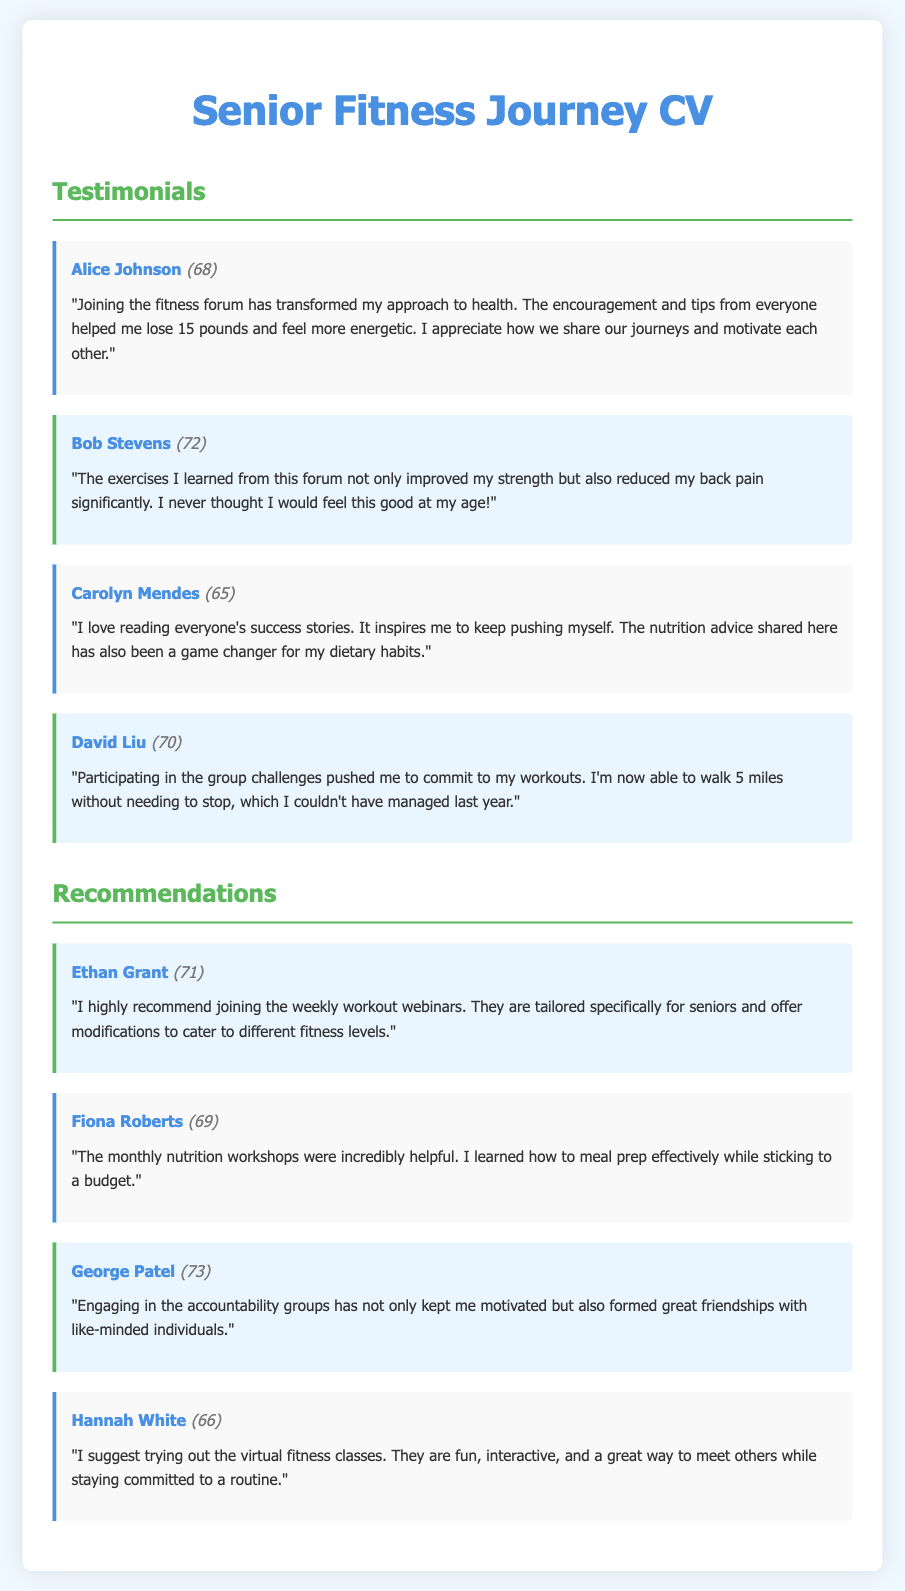What is the name of the first person to give a testimonial? The first testimonial is provided by Alice Johnson.
Answer: Alice Johnson How old is Bob Stevens? Bob Stevens is mentioned with his age given in parentheses.
Answer: 72 What was the weight loss mentioned by Alice Johnson? Alice Johnson states that she lost a specific amount of weight in her testimonial.
Answer: 15 pounds Who recommends joining the weekly workout webinars? The name associated with this recommendation is stated in the document.
Answer: Ethan Grant Which testimonial mentions improved strength? The statement regarding strength improvement is found in a specific testimonial.
Answer: Bob Stevens What type of workshops does Fiona Roberts recommend? Fiona Roberts gives a specific type of workshop in her recommendation.
Answer: Nutrition workshops How many miles can David Liu walk now? David Liu shares a specific distance he can now walk in his testimonial.
Answer: 5 miles What was the purpose of the accountability groups mentioned by George Patel? The accountability groups are discussed for their impact on motivation and friendship.
Answer: Motivation and friendships What is the general theme of the testimonials? The testimonials focus on a particular aspect of health improvement among seniors.
Answer: Health improvement 